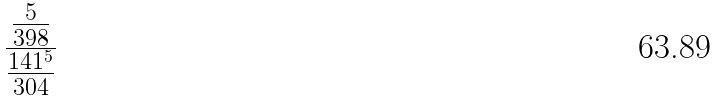Convert formula to latex. <formula><loc_0><loc_0><loc_500><loc_500>\frac { \frac { 5 } { 3 9 8 } } { \frac { 1 4 1 ^ { 5 } } { 3 0 4 } }</formula> 